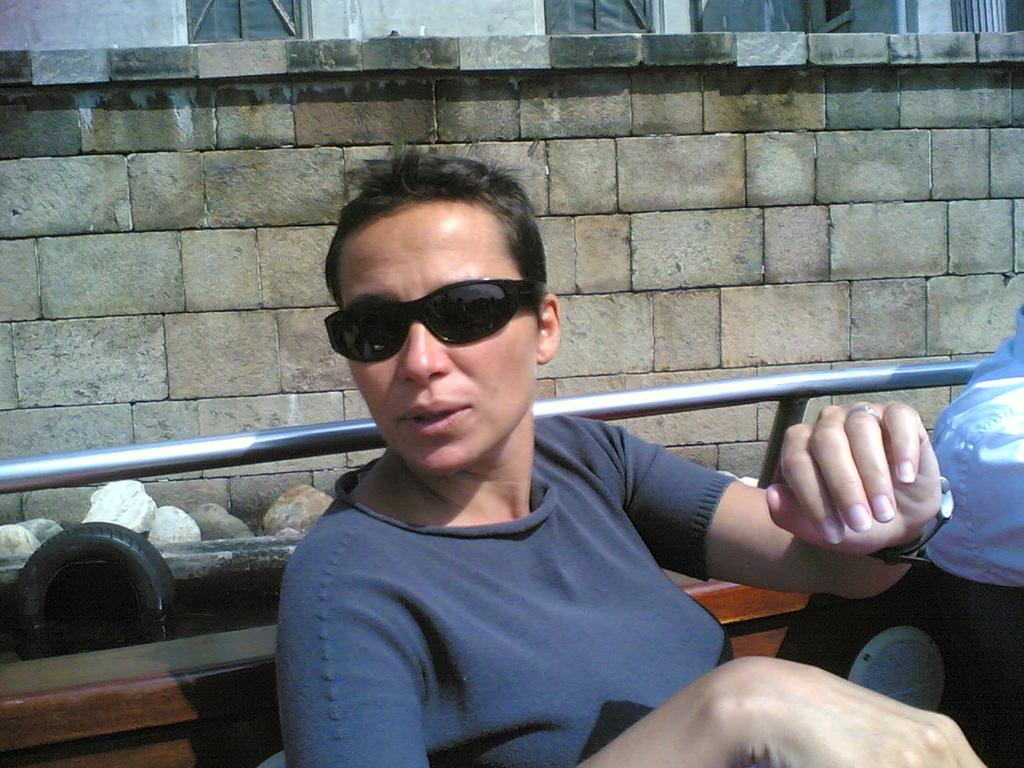Who is present in the image? There is a woman in the image. What is the woman doing in the image? The woman is sitting in a boat. What is the woman wearing in the image? The woman is wearing sunglasses. What can be seen in the background of the image? There is a wall in the background of the image. What type of natural elements are visible in the image? There are stones visible in the image. What object can be seen in the water in the image? There is a tyre in the water. What reason does the woman give for sitting in the boat in the image? The image does not provide any information about the woman's reason for sitting in the boat, so we cannot determine her reason from the image. 